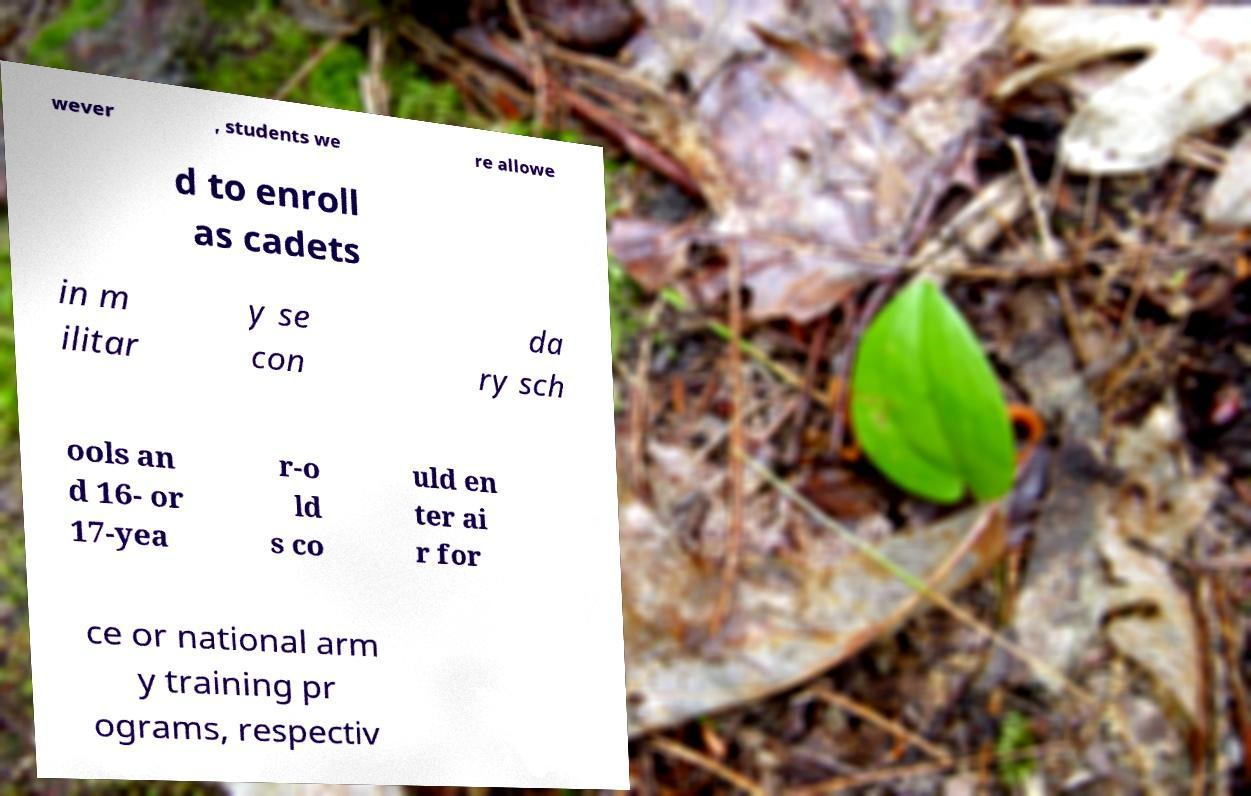Can you accurately transcribe the text from the provided image for me? wever , students we re allowe d to enroll as cadets in m ilitar y se con da ry sch ools an d 16- or 17-yea r-o ld s co uld en ter ai r for ce or national arm y training pr ograms, respectiv 